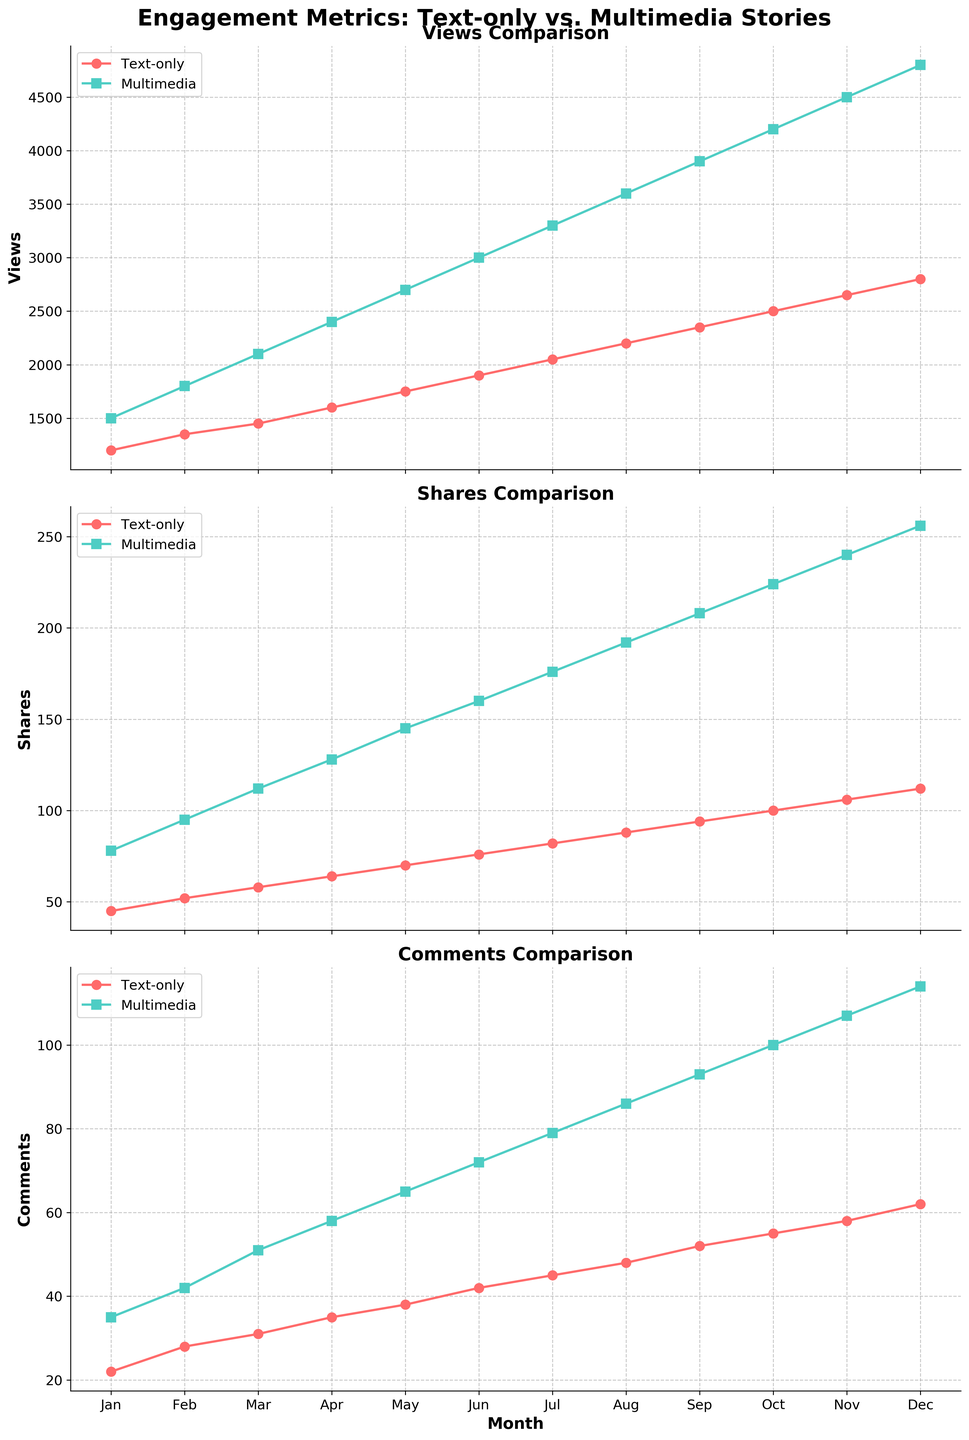What month shows the highest number of multimedia views? To determine the month with the highest number of multimedia views, look at the graph for 'Views Comparison' and find the peak of the multimedia line. The highest point is in December.
Answer: December Which type of story had more views in June, text-only or multimedia? Compare the points for text-only and multimedia stories on the 'Views Comparison' graph at the June mark. Multimedia stories have a higher point.
Answer: Multimedia By how much did the number of multimedia comments increase from January to December? Check the 'Comments Comparison' graph and note the number of multimedia comments in January and December (35 and 114, respectively). Subtract the January value from the December value (114 − 35).
Answer: 79 What's the average number of text-only shares over the year? Sum the text-only shares for each month (45 + 52 + 58 + 64 + 70 + 76 + 82 + 88 + 94 + 100 + 106 + 112) to get 947. Divide by 12 months.
Answer: 78.92 Which type of story consistently had more shares throughout the year? By checking the 'Shares Comparison' graph, observe the trend lines. The multimedia line is consistently above the text-only line.
Answer: Multimedia What's the combined total of text-only and multimedia views in September? Check the 'Views Comparison' for September values (text-only: 2350; multimedia: 3900) and add them.
Answer: 6250 Between which consecutive months was the increase in multimedia views the largest? Look at the differences between consecutive months for multimedia views. The largest increase is from November (4500) to December (4800), an increase of 300.
Answer: November to December What is the smallest number of comments any month received for text-only stories? Refer to the 'Comments Comparison' graph and find the lowest point on the text-only line. The smallest value is 22 in January.
Answer: 22 During which month was the difference in views between text-only and multimedia stories the greatest? For each month, find the difference between text-only and multimedia views. The largest difference is in December (4800 - 2800 = 2000).
Answer: December What trend can be observed in the comments for both types of stories over the year? Observe the 'Comments Comparison' graph. Both text-only and multimedia comments show an increasing trend over the months.
Answer: Increasing 